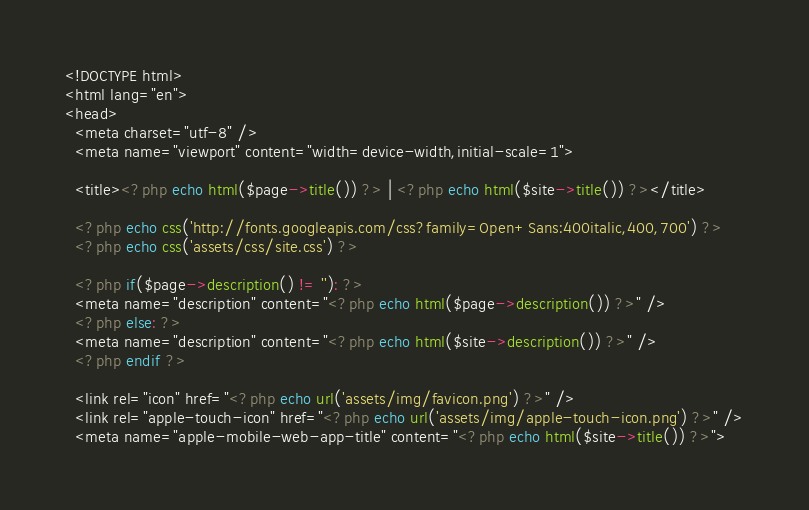<code> <loc_0><loc_0><loc_500><loc_500><_PHP_><!DOCTYPE html>
<html lang="en">
<head>
  <meta charset="utf-8" />
  <meta name="viewport" content="width=device-width,initial-scale=1">

  <title><?php echo html($page->title()) ?> | <?php echo html($site->title()) ?></title>

  <?php echo css('http://fonts.googleapis.com/css?family=Open+Sans:400italic,400,700') ?>
  <?php echo css('assets/css/site.css') ?>

  <?php if($page->description() != ''): ?>
  <meta name="description" content="<?php echo html($page->description()) ?>" />
  <?php else: ?>
  <meta name="description" content="<?php echo html($site->description()) ?>" />
  <?php endif ?>

  <link rel="icon" href="<?php echo url('assets/img/favicon.png') ?>" />
  <link rel="apple-touch-icon" href="<?php echo url('assets/img/apple-touch-icon.png') ?>" />
  <meta name="apple-mobile-web-app-title" content="<?php echo html($site->title()) ?>"></code> 